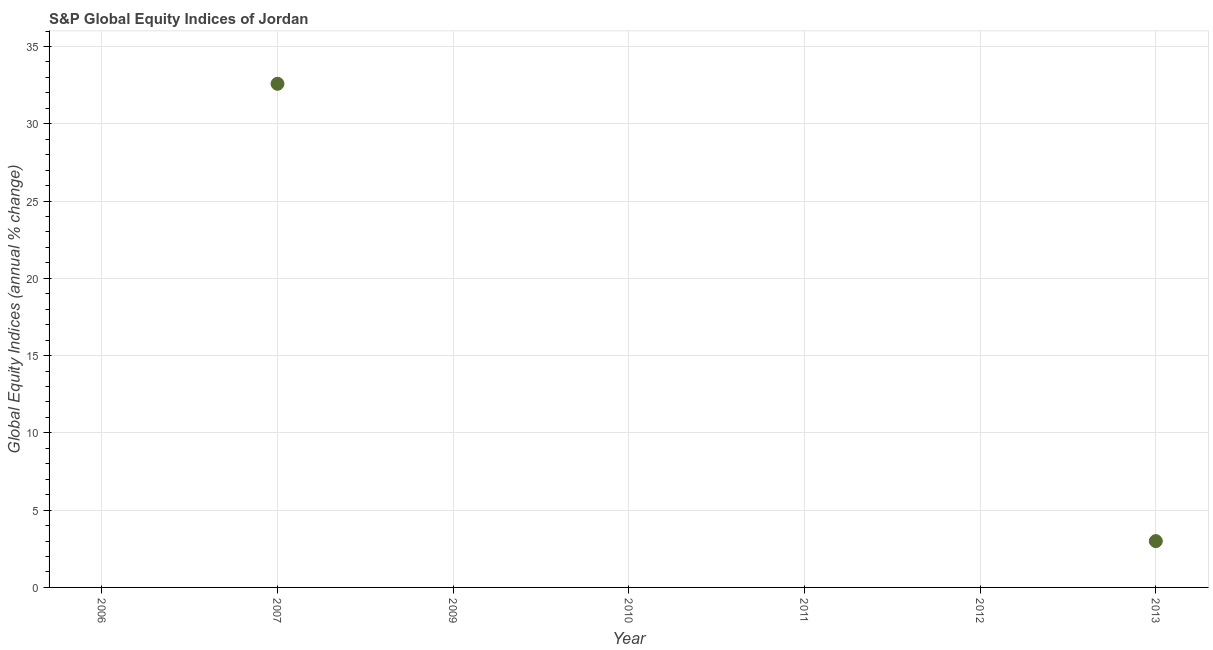Across all years, what is the maximum s&p global equity indices?
Your response must be concise. 32.59. What is the sum of the s&p global equity indices?
Offer a very short reply. 35.58. What is the average s&p global equity indices per year?
Keep it short and to the point. 5.08. In how many years, is the s&p global equity indices greater than 4 %?
Offer a very short reply. 1. What is the ratio of the s&p global equity indices in 2007 to that in 2013?
Offer a very short reply. 10.88. What is the difference between the highest and the lowest s&p global equity indices?
Ensure brevity in your answer.  32.59. In how many years, is the s&p global equity indices greater than the average s&p global equity indices taken over all years?
Keep it short and to the point. 1. Does the s&p global equity indices monotonically increase over the years?
Ensure brevity in your answer.  No. How many dotlines are there?
Provide a short and direct response. 1. How many years are there in the graph?
Give a very brief answer. 7. What is the difference between two consecutive major ticks on the Y-axis?
Give a very brief answer. 5. Are the values on the major ticks of Y-axis written in scientific E-notation?
Ensure brevity in your answer.  No. Does the graph contain grids?
Keep it short and to the point. Yes. What is the title of the graph?
Make the answer very short. S&P Global Equity Indices of Jordan. What is the label or title of the Y-axis?
Offer a very short reply. Global Equity Indices (annual % change). What is the Global Equity Indices (annual % change) in 2007?
Give a very brief answer. 32.59. What is the Global Equity Indices (annual % change) in 2009?
Your answer should be compact. 0. What is the Global Equity Indices (annual % change) in 2010?
Provide a short and direct response. 0. What is the Global Equity Indices (annual % change) in 2012?
Ensure brevity in your answer.  0. What is the Global Equity Indices (annual % change) in 2013?
Your answer should be very brief. 3. What is the difference between the Global Equity Indices (annual % change) in 2007 and 2013?
Your answer should be compact. 29.59. What is the ratio of the Global Equity Indices (annual % change) in 2007 to that in 2013?
Keep it short and to the point. 10.88. 